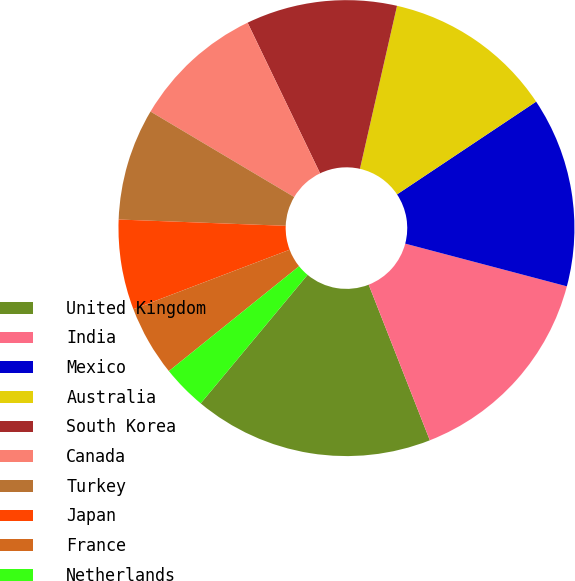Convert chart to OTSL. <chart><loc_0><loc_0><loc_500><loc_500><pie_chart><fcel>United Kingdom<fcel>India<fcel>Mexico<fcel>Australia<fcel>South Korea<fcel>Canada<fcel>Turkey<fcel>Japan<fcel>France<fcel>Netherlands<nl><fcel>17.0%<fcel>14.93%<fcel>13.47%<fcel>12.08%<fcel>10.7%<fcel>9.32%<fcel>7.94%<fcel>6.39%<fcel>5.0%<fcel>3.17%<nl></chart> 